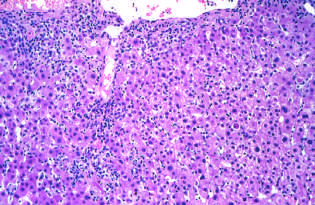how is acute viral hepatitis characterized?
Answer the question using a single word or phrase. By predominantly lymphocytic infiltrate 